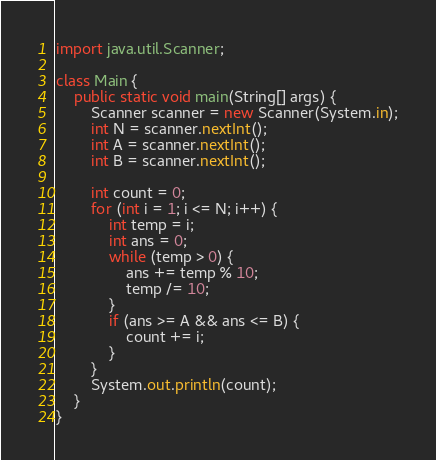Convert code to text. <code><loc_0><loc_0><loc_500><loc_500><_Java_>import java.util.Scanner;

class Main {
    public static void main(String[] args) {
        Scanner scanner = new Scanner(System.in);
        int N = scanner.nextInt();
        int A = scanner.nextInt();
        int B = scanner.nextInt();

        int count = 0;
        for (int i = 1; i <= N; i++) {
            int temp = i;
            int ans = 0;
            while (temp > 0) {
                ans += temp % 10;
                temp /= 10;
            }
            if (ans >= A && ans <= B) {
                count += i;
            }
        }
        System.out.println(count);
    }
}
</code> 